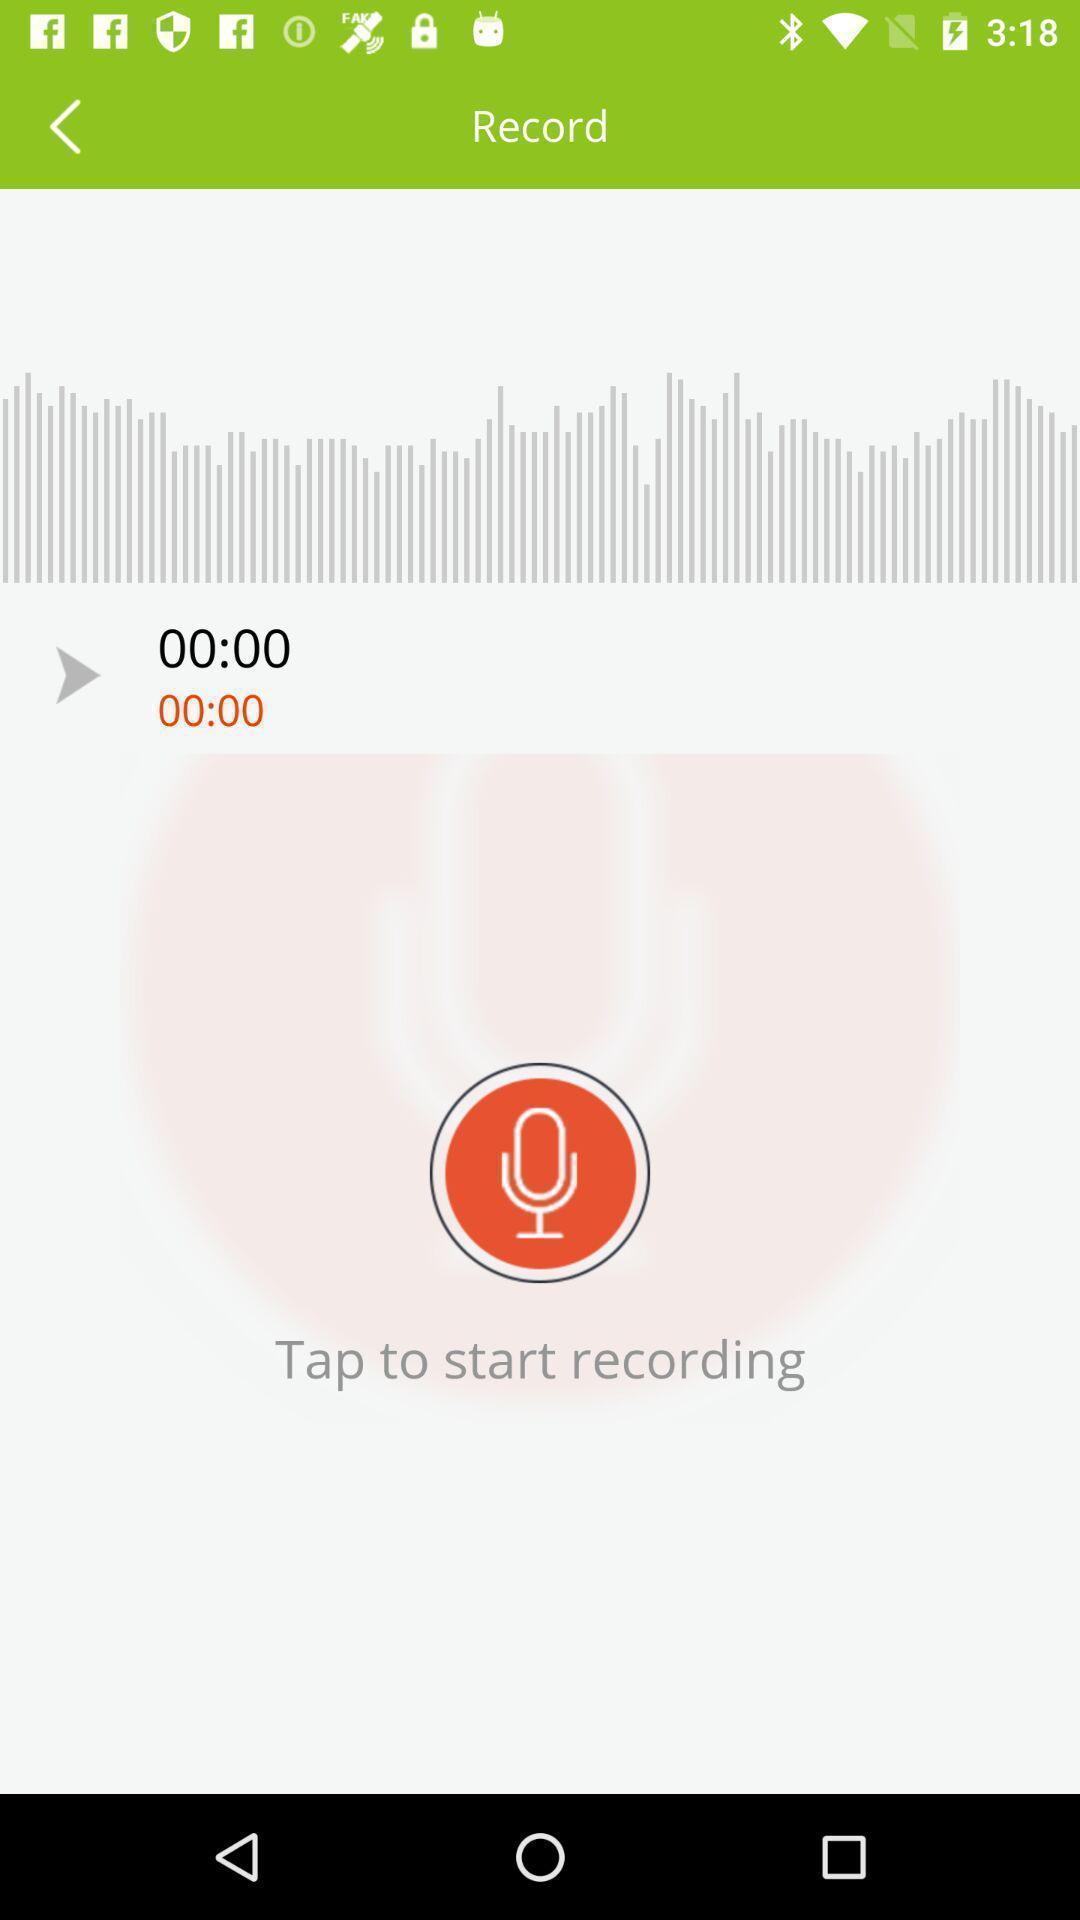What details can you identify in this image? Screen displaying a recorder icon in a podcast application. 